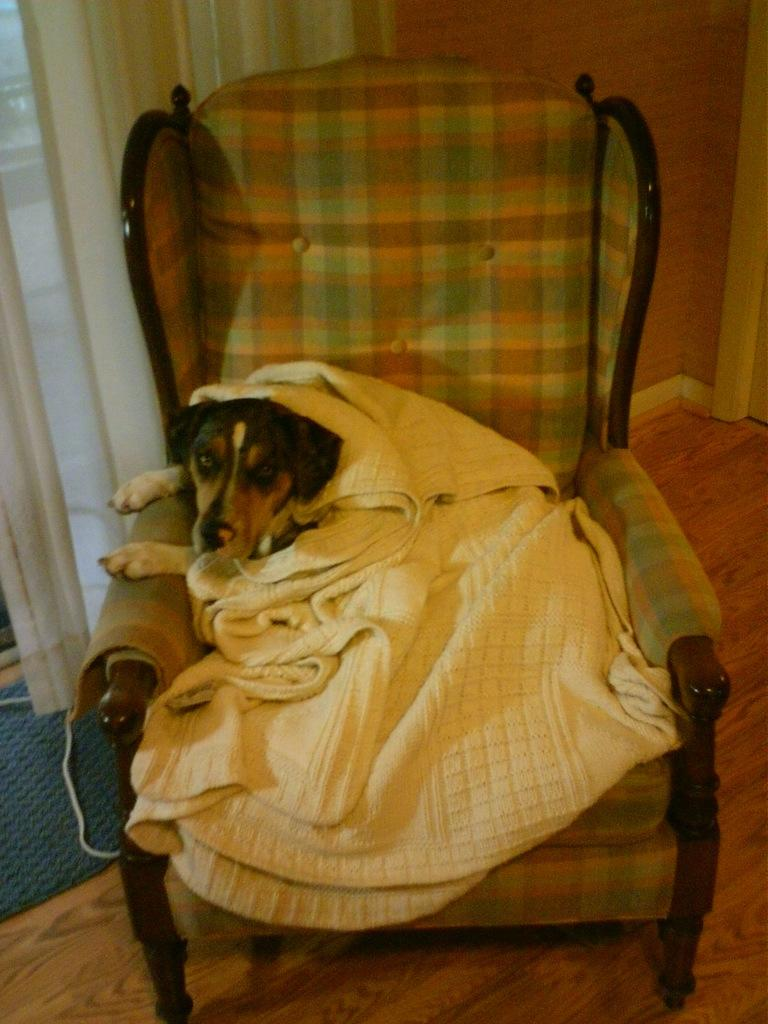What type of animal is in the image? There is a dog in the image. What is the dog doing in the image? The dog is sitting on a chair. Is there anything covering the dog? Yes, there is a cloth on the dog. What can be seen at the bottom of the image? The floor is visible at the bottom of the image. What is located on the left side of the image? There is a mat on the left side of the image. What is the purpose of the bomb in the image? There is no bomb present in the image. 